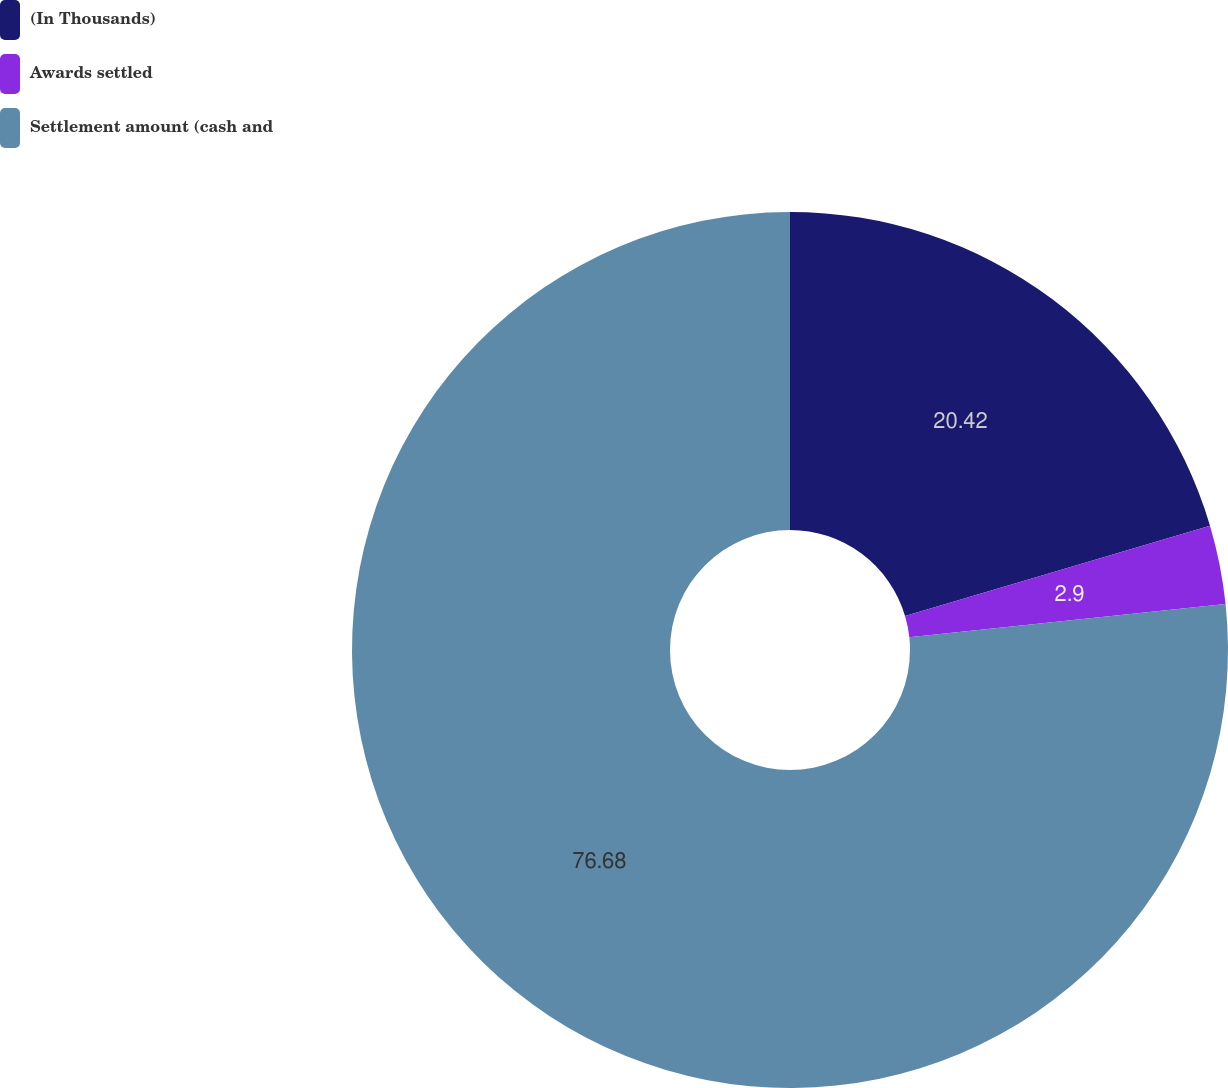Convert chart to OTSL. <chart><loc_0><loc_0><loc_500><loc_500><pie_chart><fcel>(In Thousands)<fcel>Awards settled<fcel>Settlement amount (cash and<nl><fcel>20.42%<fcel>2.9%<fcel>76.67%<nl></chart> 